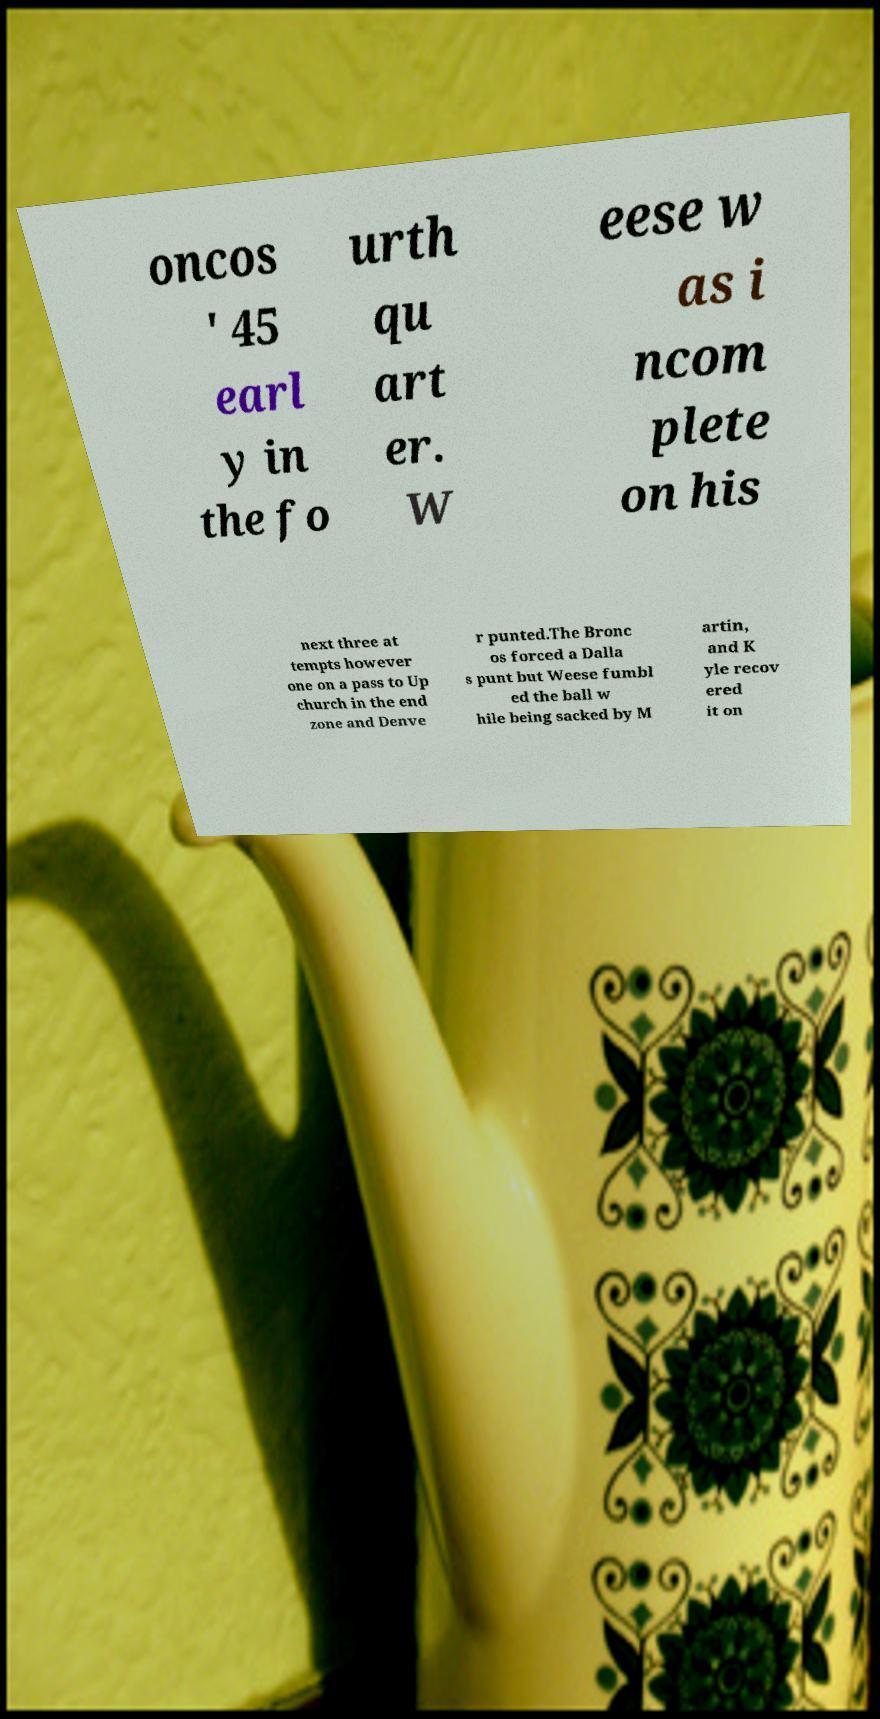What messages or text are displayed in this image? I need them in a readable, typed format. oncos ' 45 earl y in the fo urth qu art er. W eese w as i ncom plete on his next three at tempts however one on a pass to Up church in the end zone and Denve r punted.The Bronc os forced a Dalla s punt but Weese fumbl ed the ball w hile being sacked by M artin, and K yle recov ered it on 